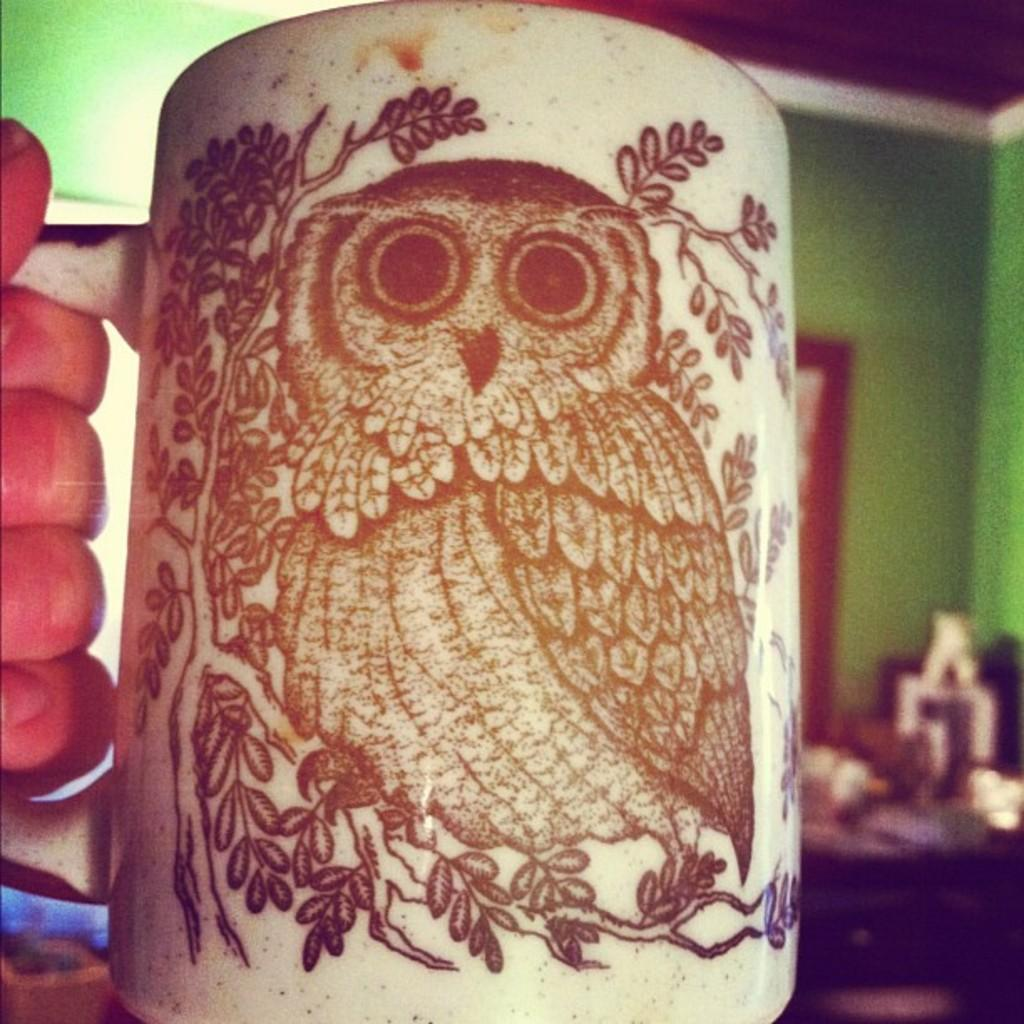What is the human hand holding in the image? A human hand is holding a cup in the image. What can be seen in the background of the image? There is a wall and a roof visible in the background of the image. What is located on the right side of the image? There are some objects present on the right side of the image. Can you describe the leg of the person driving the car in the image? There is no person driving a car in the image, nor is there any leg visible. 